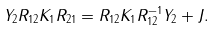Convert formula to latex. <formula><loc_0><loc_0><loc_500><loc_500>Y _ { 2 } R _ { 1 2 } K _ { 1 } R _ { 2 1 } = R _ { 1 2 } K _ { 1 } R _ { 1 2 } ^ { - 1 } Y _ { 2 } + J .</formula> 